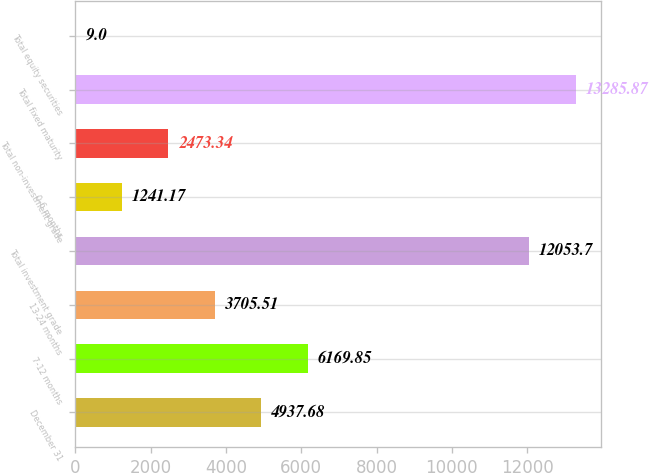Convert chart to OTSL. <chart><loc_0><loc_0><loc_500><loc_500><bar_chart><fcel>December 31<fcel>7-12 months<fcel>13-24 months<fcel>Total investment grade<fcel>0-6 months<fcel>Total non-investment grade<fcel>Total fixed maturity<fcel>Total equity securities<nl><fcel>4937.68<fcel>6169.85<fcel>3705.51<fcel>12053.7<fcel>1241.17<fcel>2473.34<fcel>13285.9<fcel>9<nl></chart> 